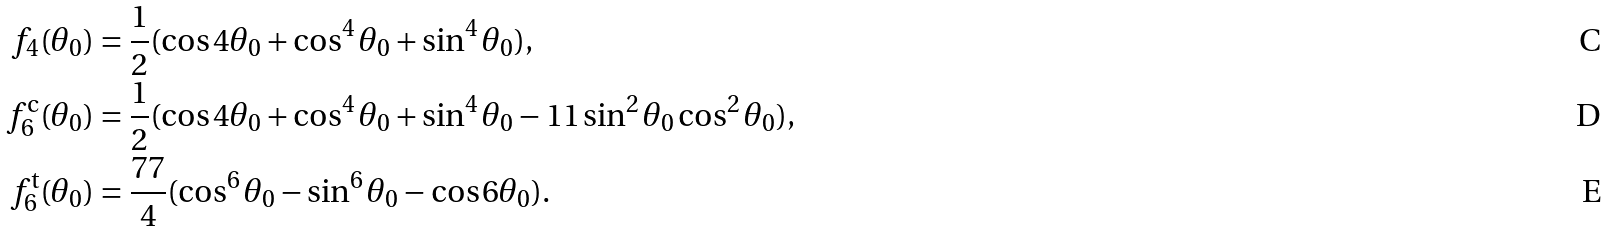<formula> <loc_0><loc_0><loc_500><loc_500>f _ { 4 } ( \theta _ { 0 } ) & = \frac { 1 } { 2 } ( \cos 4 \theta _ { 0 } + \cos ^ { 4 } \theta _ { 0 } + \sin ^ { 4 } \theta _ { 0 } ) , \\ f _ { 6 } ^ { \text {c} } ( \theta _ { 0 } ) & = \frac { 1 } { 2 } ( \cos 4 \theta _ { 0 } + \cos ^ { 4 } \theta _ { 0 } + \sin ^ { 4 } \theta _ { 0 } - 1 1 \sin ^ { 2 } \theta _ { 0 } \cos ^ { 2 } \theta _ { 0 } ) , \\ f _ { 6 } ^ { \text {t} } ( \theta _ { 0 } ) & = \frac { 7 7 } { 4 } ( \cos ^ { 6 } \theta _ { 0 } - \sin ^ { 6 } \theta _ { 0 } - \cos 6 \theta _ { 0 } ) .</formula> 